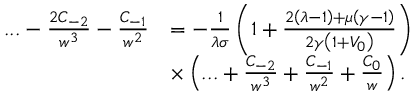<formula> <loc_0><loc_0><loc_500><loc_500>\begin{array} { r l } { \dots - \frac { 2 C _ { - 2 } } { w ^ { 3 } } - \frac { C _ { - 1 } } { w ^ { 2 } } } & { = - \frac { 1 } { \lambda \sigma } \left ( 1 + \frac { 2 \left ( \lambda - 1 \right ) + \mu \left ( \gamma - 1 \right ) } { 2 \gamma \left ( 1 + V _ { 0 } \right ) } \right ) } \\ & { \times \left ( \dots + \frac { C _ { - 2 } } { w ^ { 3 } } + \frac { C _ { - 1 } } { w ^ { 2 } } + \frac { C _ { 0 } } { w } \right ) . } \end{array}</formula> 